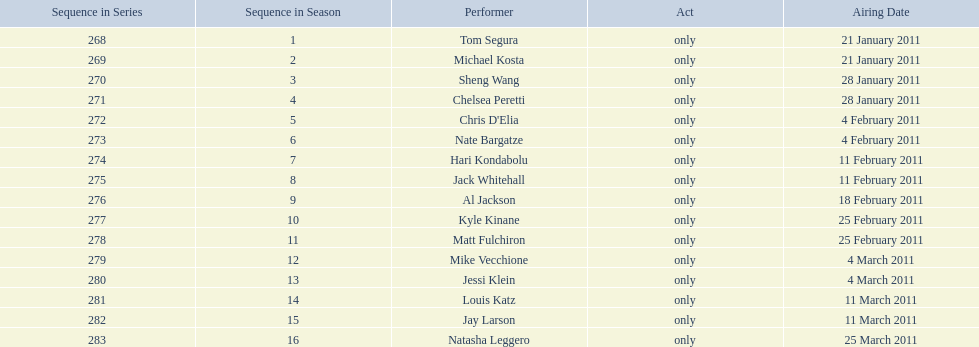Did al jackson air before or after kyle kinane? Before. 